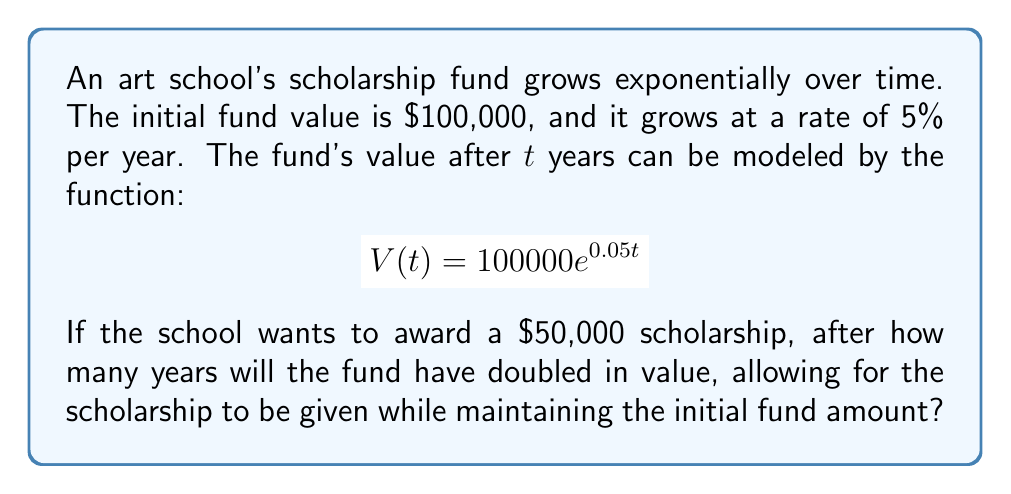Could you help me with this problem? Let's approach this step-by-step:

1) We need to find when the fund will have doubled. This means we're looking for the time $t$ when:

   $$V(t) = 200000$$

2) We can set up the equation:

   $$200000 = 100000e^{0.05t}$$

3) Divide both sides by 100000:

   $$2 = e^{0.05t}$$

4) Take the natural log of both sides:

   $$\ln(2) = \ln(e^{0.05t})$$

5) Simplify the right side using the properties of logarithms:

   $$\ln(2) = 0.05t$$

6) Solve for $t$:

   $$t = \frac{\ln(2)}{0.05}$$

7) Calculate the value:

   $$t = \frac{0.693147...}{0.05} \approx 13.86$$

8) Therefore, it will take approximately 13.86 years for the fund to double.

9) To verify if this allows for the $50,000 scholarship while maintaining the initial amount:
   
   Initial amount: $100,000
   Doubled amount: $200,000
   After scholarship: $200,000 - $50,000 = $150,000

   Indeed, $150,000 > $100,000, so the initial amount is maintained.
Answer: 13.86 years 